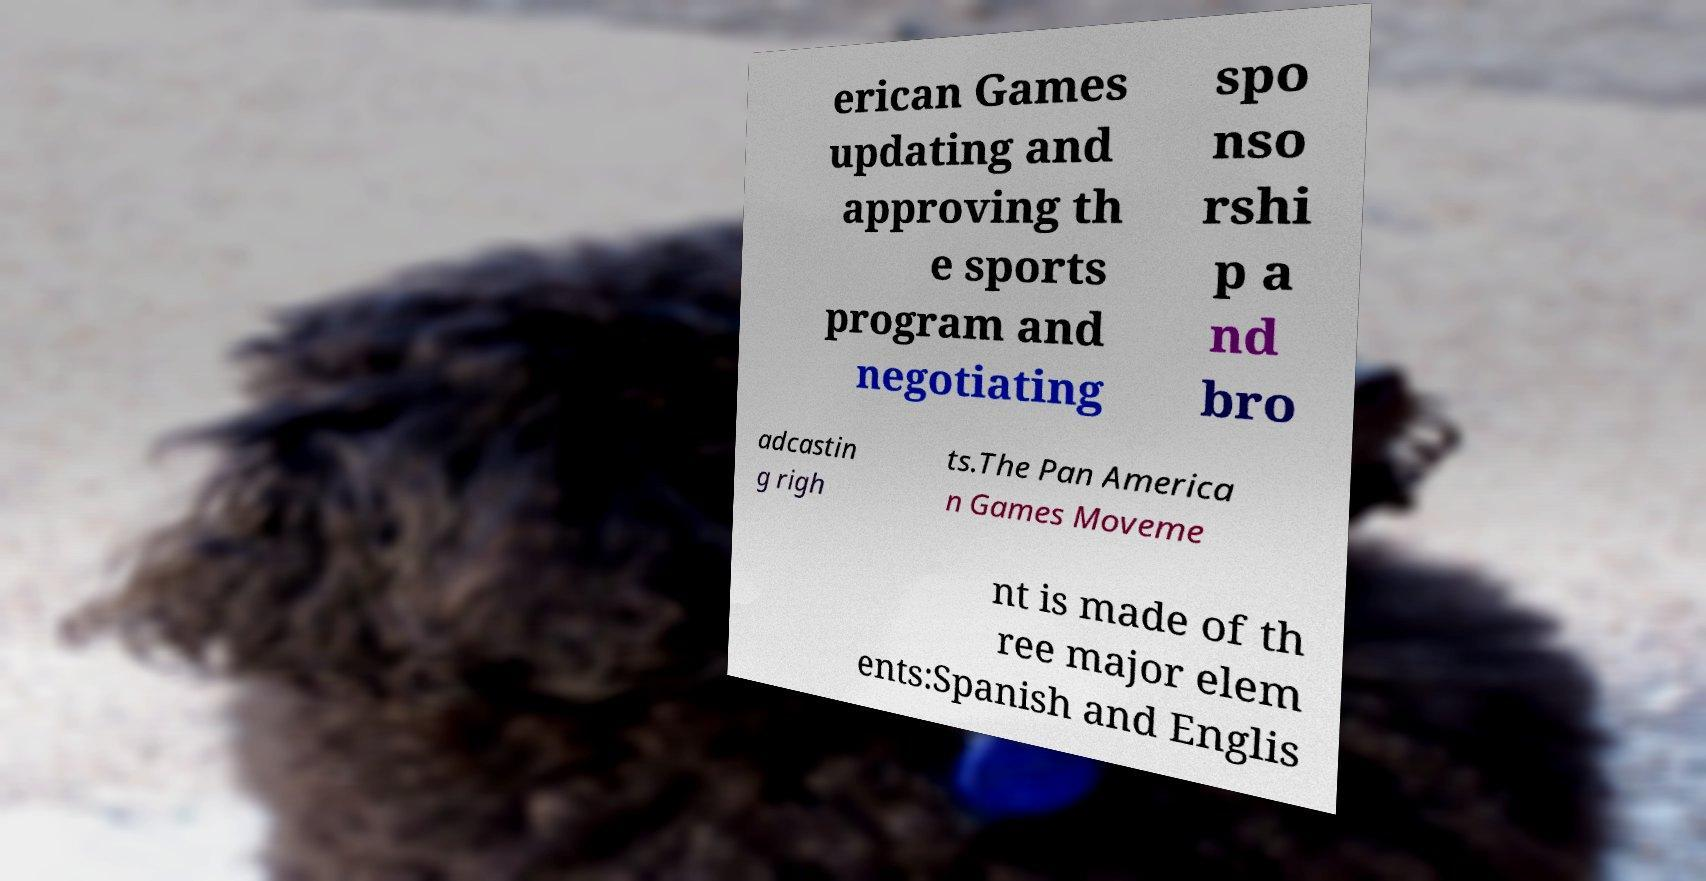There's text embedded in this image that I need extracted. Can you transcribe it verbatim? erican Games updating and approving th e sports program and negotiating spo nso rshi p a nd bro adcastin g righ ts.The Pan America n Games Moveme nt is made of th ree major elem ents:Spanish and Englis 